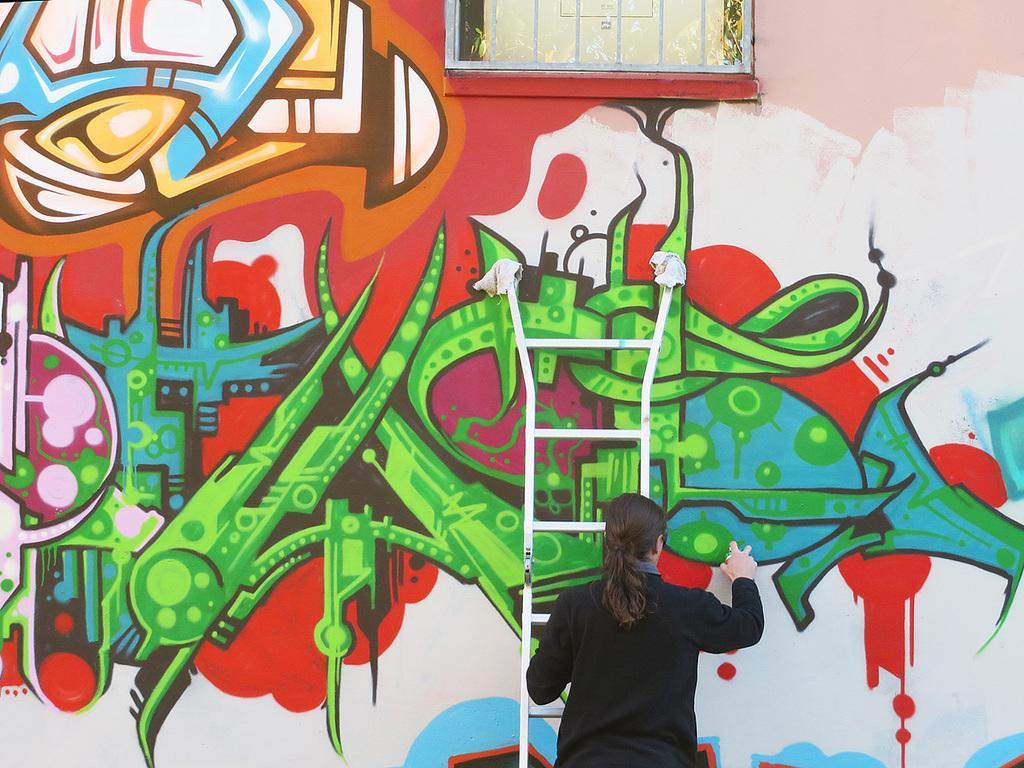Please provide a concise description of this image. In the foreground of this image, there is a woman on a ladder and doing graffiti painting on the wall. 